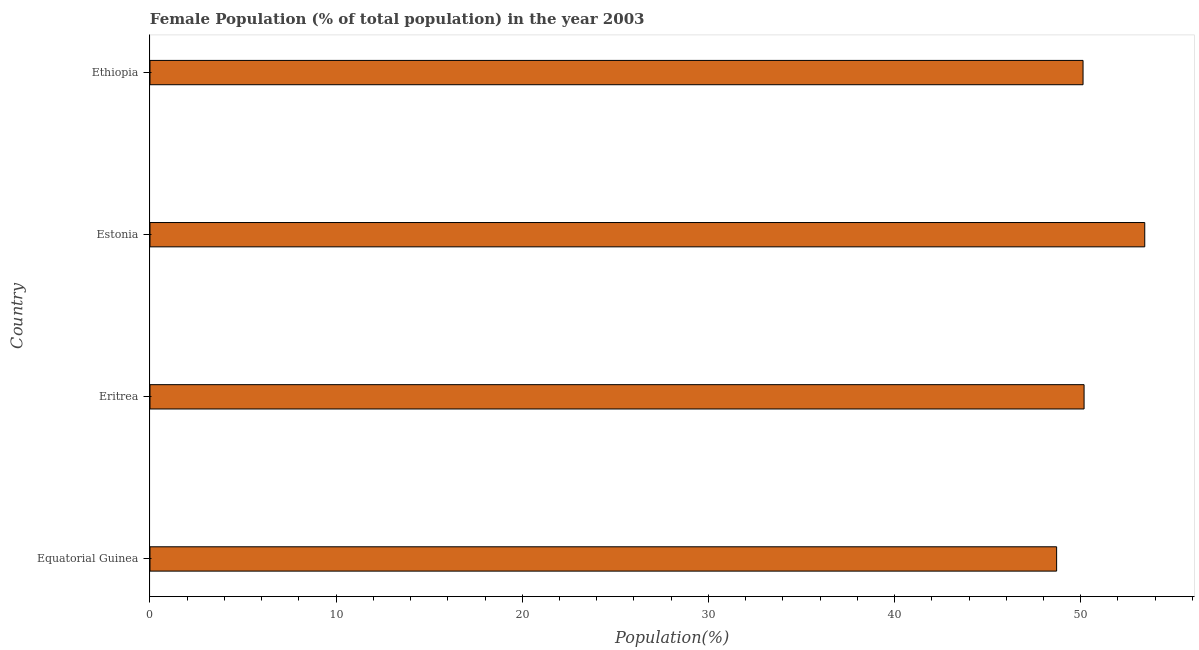What is the title of the graph?
Your answer should be very brief. Female Population (% of total population) in the year 2003. What is the label or title of the X-axis?
Offer a very short reply. Population(%). What is the female population in Eritrea?
Provide a succinct answer. 50.18. Across all countries, what is the maximum female population?
Your response must be concise. 53.44. Across all countries, what is the minimum female population?
Keep it short and to the point. 48.71. In which country was the female population maximum?
Provide a succinct answer. Estonia. In which country was the female population minimum?
Your response must be concise. Equatorial Guinea. What is the sum of the female population?
Give a very brief answer. 202.45. What is the difference between the female population in Equatorial Guinea and Eritrea?
Provide a succinct answer. -1.48. What is the average female population per country?
Provide a succinct answer. 50.61. What is the median female population?
Keep it short and to the point. 50.15. In how many countries, is the female population greater than 44 %?
Offer a very short reply. 4. Is the female population in Eritrea less than that in Estonia?
Keep it short and to the point. Yes. What is the difference between the highest and the second highest female population?
Ensure brevity in your answer.  3.26. What is the difference between the highest and the lowest female population?
Provide a succinct answer. 4.73. In how many countries, is the female population greater than the average female population taken over all countries?
Provide a short and direct response. 1. Are all the bars in the graph horizontal?
Your answer should be compact. Yes. Are the values on the major ticks of X-axis written in scientific E-notation?
Your answer should be compact. No. What is the Population(%) of Equatorial Guinea?
Your response must be concise. 48.71. What is the Population(%) of Eritrea?
Your answer should be compact. 50.18. What is the Population(%) of Estonia?
Your answer should be very brief. 53.44. What is the Population(%) of Ethiopia?
Your answer should be compact. 50.12. What is the difference between the Population(%) in Equatorial Guinea and Eritrea?
Ensure brevity in your answer.  -1.47. What is the difference between the Population(%) in Equatorial Guinea and Estonia?
Your response must be concise. -4.73. What is the difference between the Population(%) in Equatorial Guinea and Ethiopia?
Your answer should be compact. -1.42. What is the difference between the Population(%) in Eritrea and Estonia?
Ensure brevity in your answer.  -3.26. What is the difference between the Population(%) in Eritrea and Ethiopia?
Your response must be concise. 0.06. What is the difference between the Population(%) in Estonia and Ethiopia?
Make the answer very short. 3.32. What is the ratio of the Population(%) in Equatorial Guinea to that in Estonia?
Make the answer very short. 0.91. What is the ratio of the Population(%) in Equatorial Guinea to that in Ethiopia?
Give a very brief answer. 0.97. What is the ratio of the Population(%) in Eritrea to that in Estonia?
Provide a short and direct response. 0.94. What is the ratio of the Population(%) in Estonia to that in Ethiopia?
Keep it short and to the point. 1.07. 